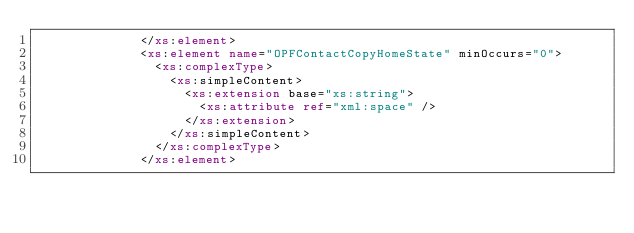Convert code to text. <code><loc_0><loc_0><loc_500><loc_500><_XML_>							</xs:element>
							<xs:element name="OPFContactCopyHomeState" minOccurs="0">
								<xs:complexType>
									<xs:simpleContent>
										<xs:extension base="xs:string">
											<xs:attribute ref="xml:space" />
										</xs:extension>
									</xs:simpleContent>
								</xs:complexType>
							</xs:element></code> 